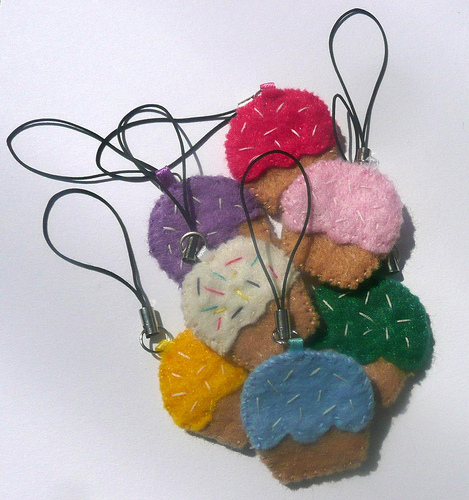<image>
Can you confirm if the cupcake is on the strong? Yes. Looking at the image, I can see the cupcake is positioned on top of the strong, with the strong providing support. 